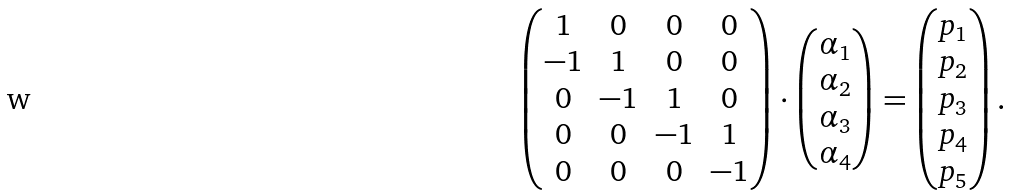Convert formula to latex. <formula><loc_0><loc_0><loc_500><loc_500>\begin{pmatrix} 1 & 0 & 0 & 0 \\ - 1 & 1 & 0 & 0 \\ 0 & - 1 & 1 & 0 \\ 0 & 0 & - 1 & 1 \\ 0 & 0 & 0 & - 1 \\ \end{pmatrix} \cdot \begin{pmatrix} \alpha _ { 1 } \\ \alpha _ { 2 } \\ \alpha _ { 3 } \\ \alpha _ { 4 } \\ \end{pmatrix} = \begin{pmatrix} p _ { 1 } \\ p _ { 2 } \\ p _ { 3 } \\ p _ { 4 } \\ p _ { 5 } \\ \end{pmatrix} .</formula> 